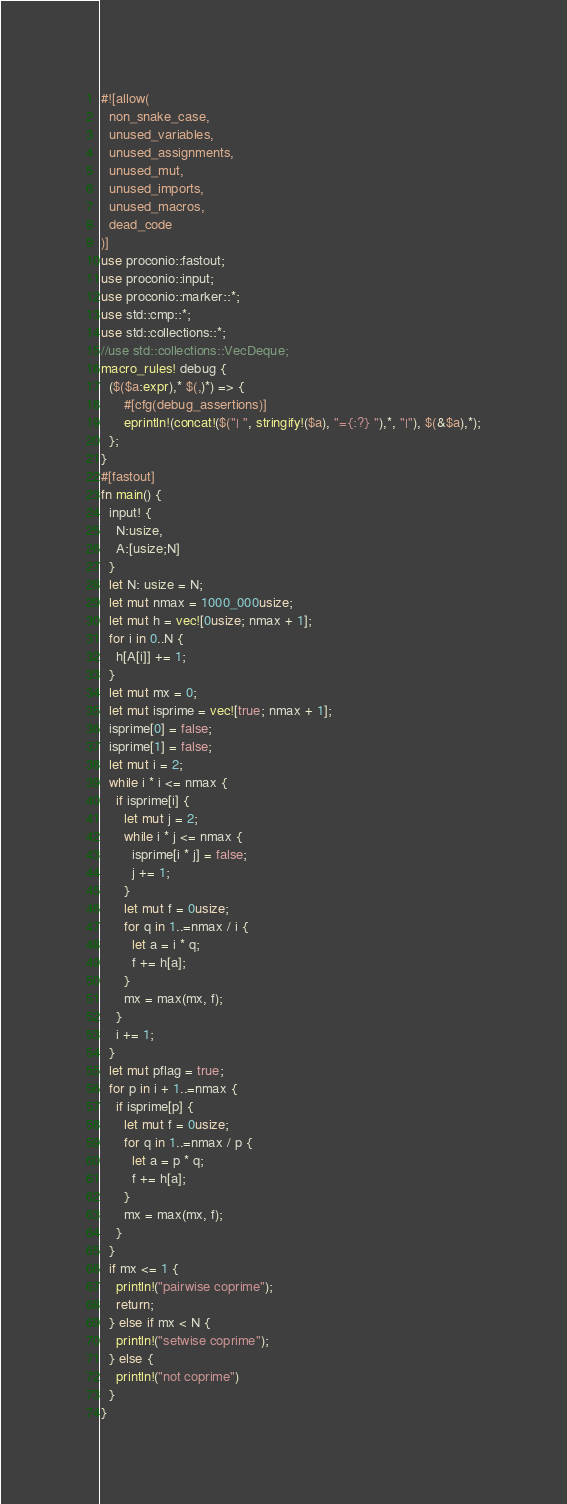<code> <loc_0><loc_0><loc_500><loc_500><_Rust_>#![allow(
  non_snake_case,
  unused_variables,
  unused_assignments,
  unused_mut,
  unused_imports,
  unused_macros,
  dead_code
)]
use proconio::fastout;
use proconio::input;
use proconio::marker::*;
use std::cmp::*;
use std::collections::*;
//use std::collections::VecDeque;
macro_rules! debug {
  ($($a:expr),* $(,)*) => {
      #[cfg(debug_assertions)]
      eprintln!(concat!($("| ", stringify!($a), "={:?} "),*, "|"), $(&$a),*);
  };
}
#[fastout]
fn main() {
  input! {
    N:usize,
    A:[usize;N]
  }
  let N: usize = N;
  let mut nmax = 1000_000usize;
  let mut h = vec![0usize; nmax + 1];
  for i in 0..N {
    h[A[i]] += 1;
  }
  let mut mx = 0;
  let mut isprime = vec![true; nmax + 1];
  isprime[0] = false;
  isprime[1] = false;
  let mut i = 2;
  while i * i <= nmax {
    if isprime[i] {
      let mut j = 2;
      while i * j <= nmax {
        isprime[i * j] = false;
        j += 1;
      }
      let mut f = 0usize;
      for q in 1..=nmax / i {
        let a = i * q;
        f += h[a];
      }
      mx = max(mx, f);
    }
    i += 1;
  }
  let mut pflag = true;
  for p in i + 1..=nmax {
    if isprime[p] {
      let mut f = 0usize;
      for q in 1..=nmax / p {
        let a = p * q;
        f += h[a];
      }
      mx = max(mx, f);
    }
  }
  if mx <= 1 {
    println!("pairwise coprime");
    return;
  } else if mx < N {
    println!("setwise coprime");
  } else {
    println!("not coprime")
  }
}
</code> 